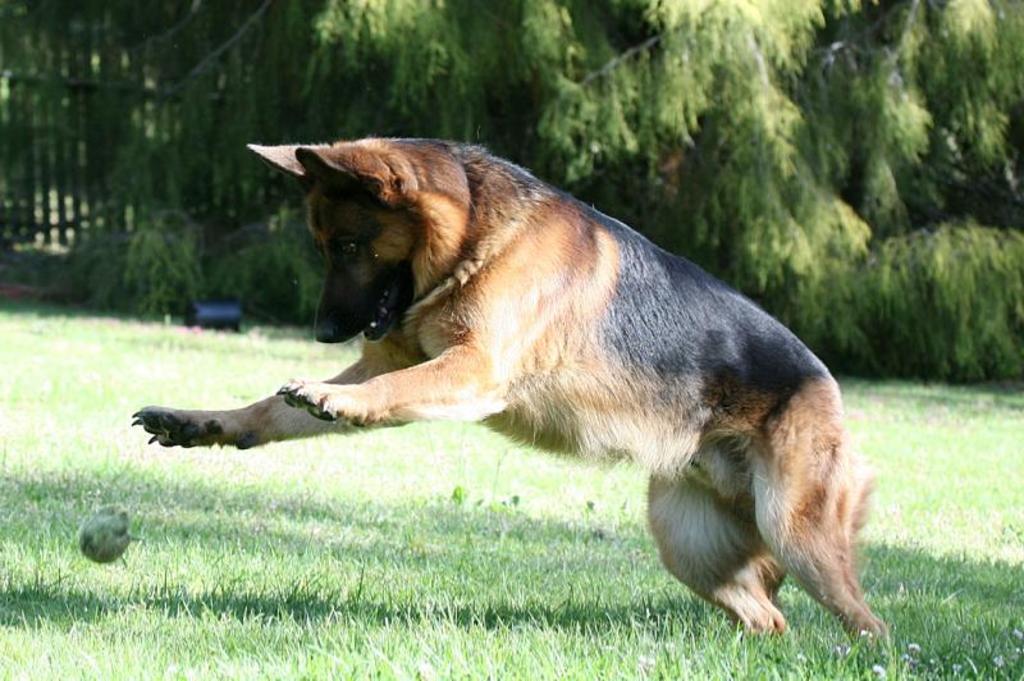Describe this image in one or two sentences. In this picture, we see a dog. It is in brown and black color. It is trying to catch a ball. At the bottom, we see the grass. There are trees and a wooden fence in the background. In the background, we see an object in black color. 